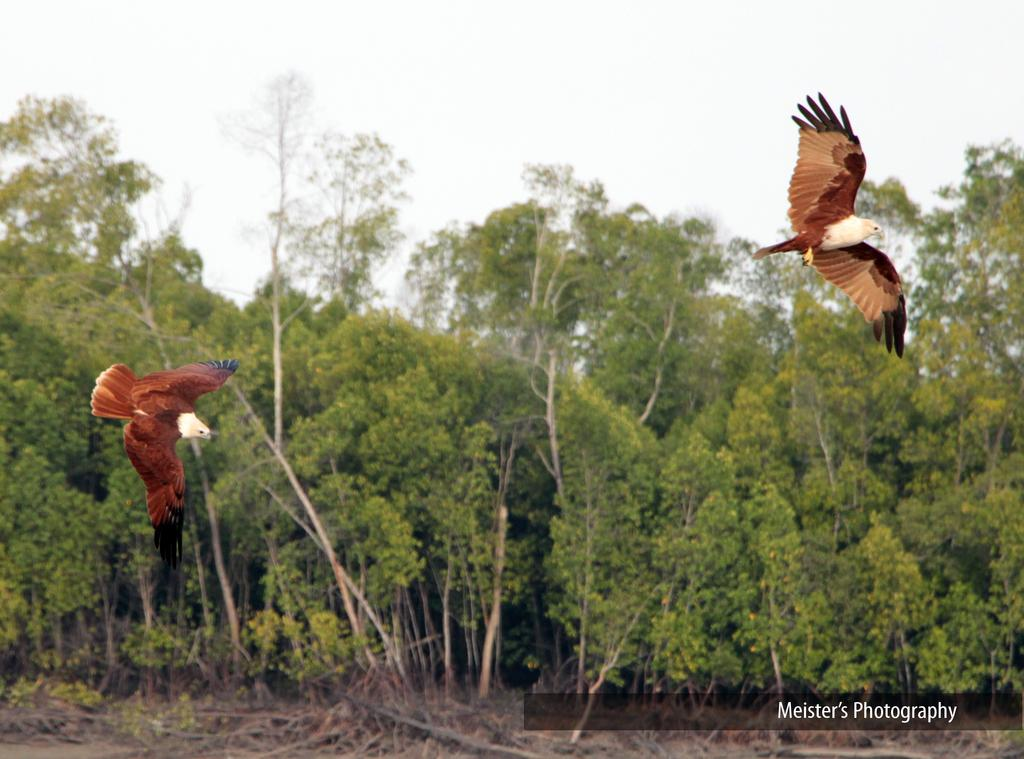How many birds can be seen in the image? There are two birds in the image. What else is present in the image besides the birds? There is text and trees visible in the image. What can be seen in the background of the image? The sky is visible in the image. Based on the presence of the sky and the absence of any artificial light sources, can we infer the time of day when the image was taken? Yes, the image was likely taken during the day. Can you tell me where the dog is located in the image? There is no dog present in the image. What type of market is depicted in the image? There is no market present in the image. 